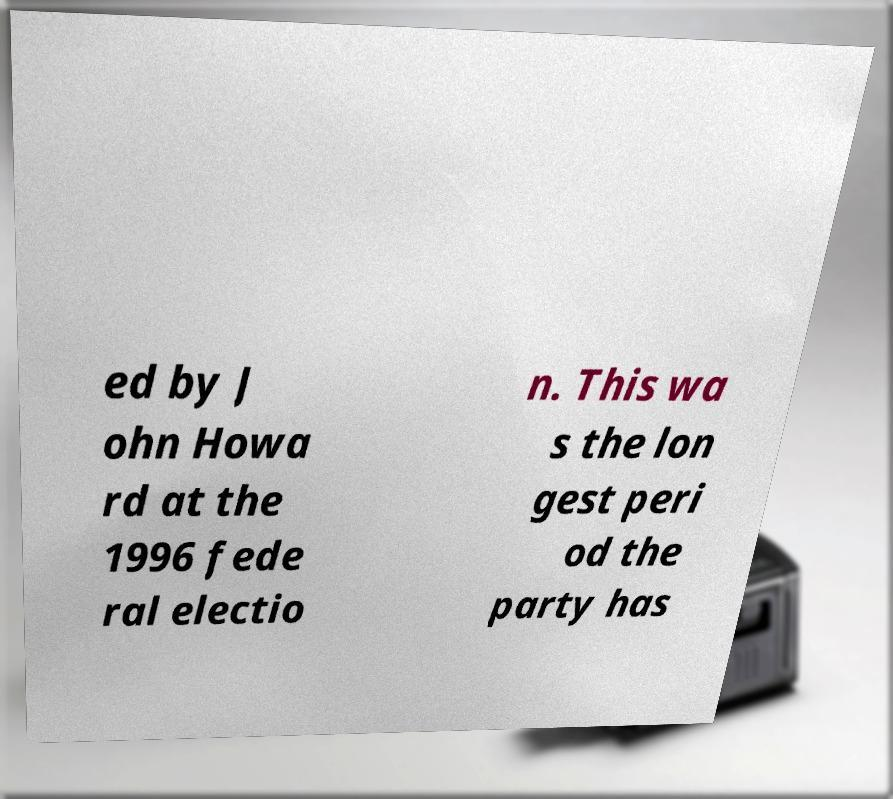Could you extract and type out the text from this image? ed by J ohn Howa rd at the 1996 fede ral electio n. This wa s the lon gest peri od the party has 